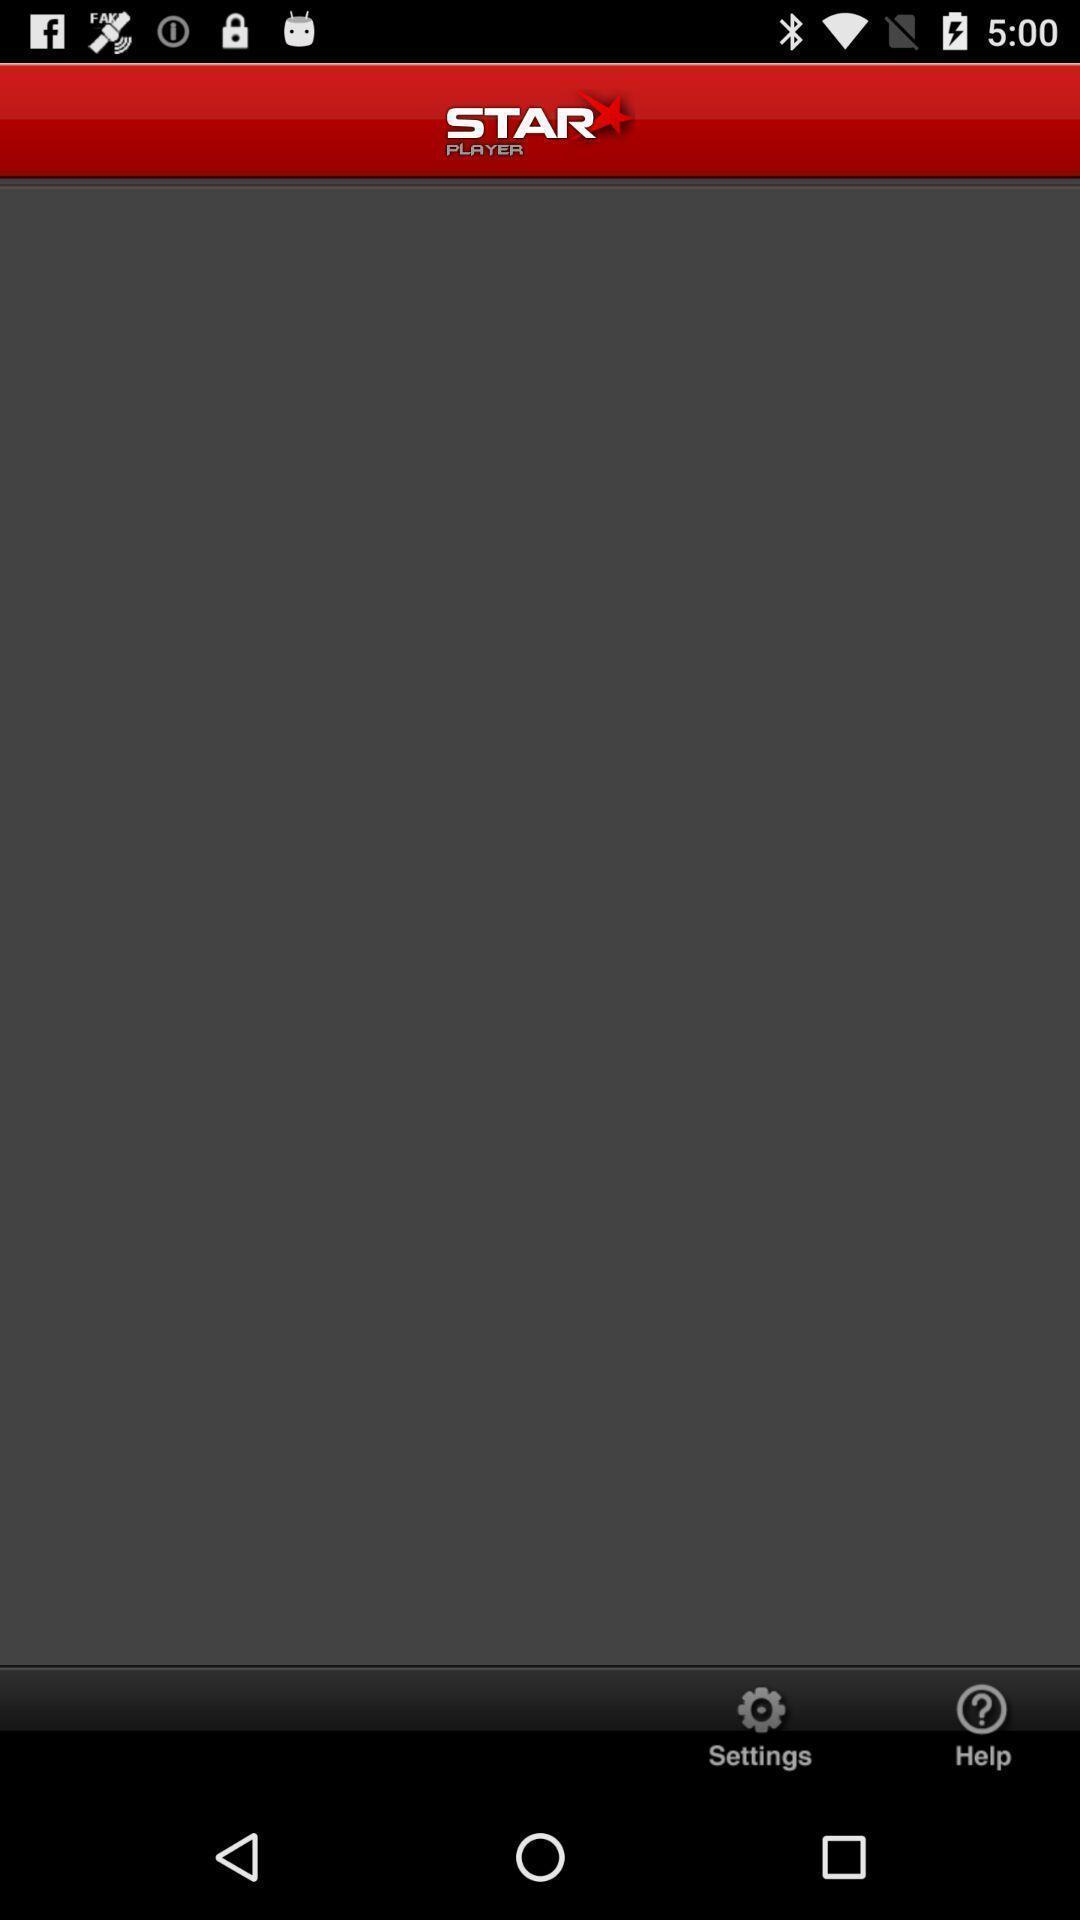Describe the visual elements of this screenshot. Window displaying a video player app. 